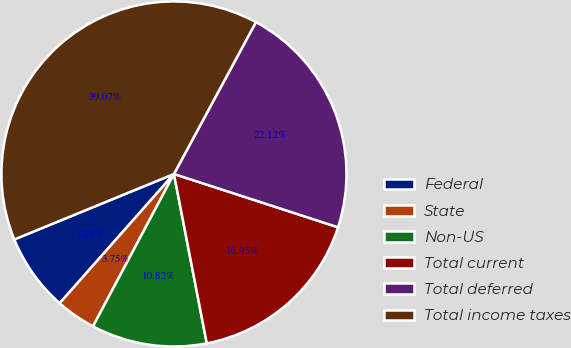Convert chart. <chart><loc_0><loc_0><loc_500><loc_500><pie_chart><fcel>Federal<fcel>State<fcel>Non-US<fcel>Total current<fcel>Total deferred<fcel>Total income taxes<nl><fcel>7.28%<fcel>3.75%<fcel>10.82%<fcel>16.95%<fcel>22.12%<fcel>39.07%<nl></chart> 